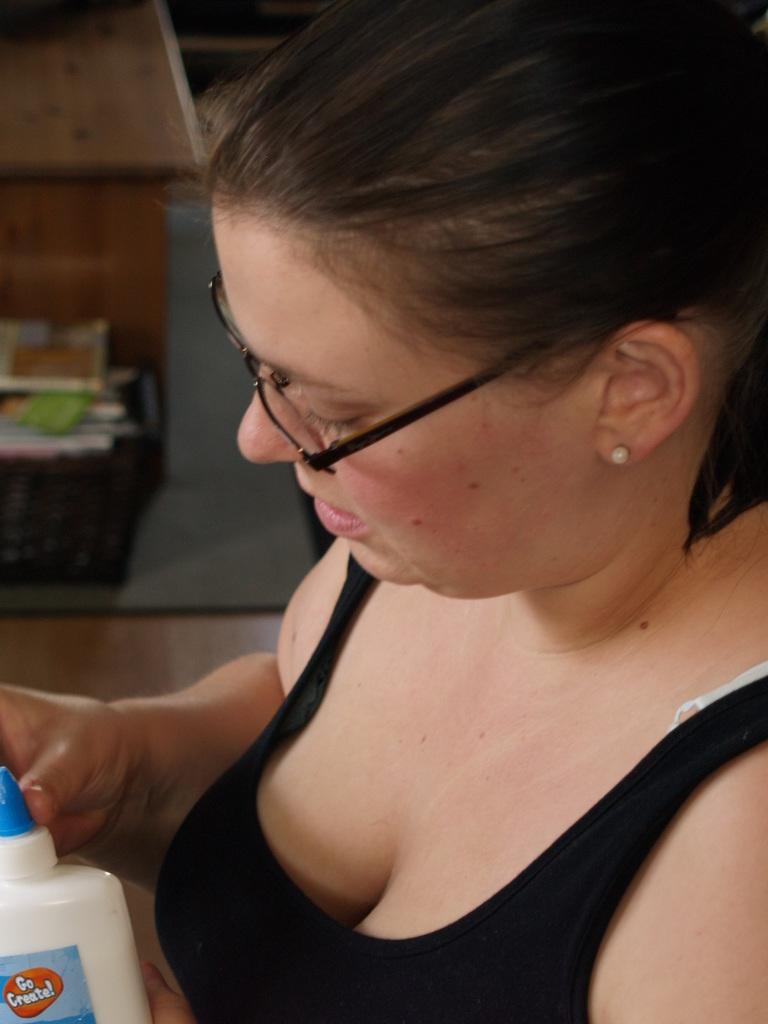Who is the main subject in the image? There is a lady in the center of the image. What is the lady wearing? The lady is wearing glasses. What is the lady holding in the image? The lady is holding a bottle. What can be seen in the background of the image? There are objects on a table in the background of the image. How much value does the lady place on the objects she is holding in the image? The value placed on the objects cannot be determined from the image alone, as it does not provide information about the lady's thoughts or emotions. 